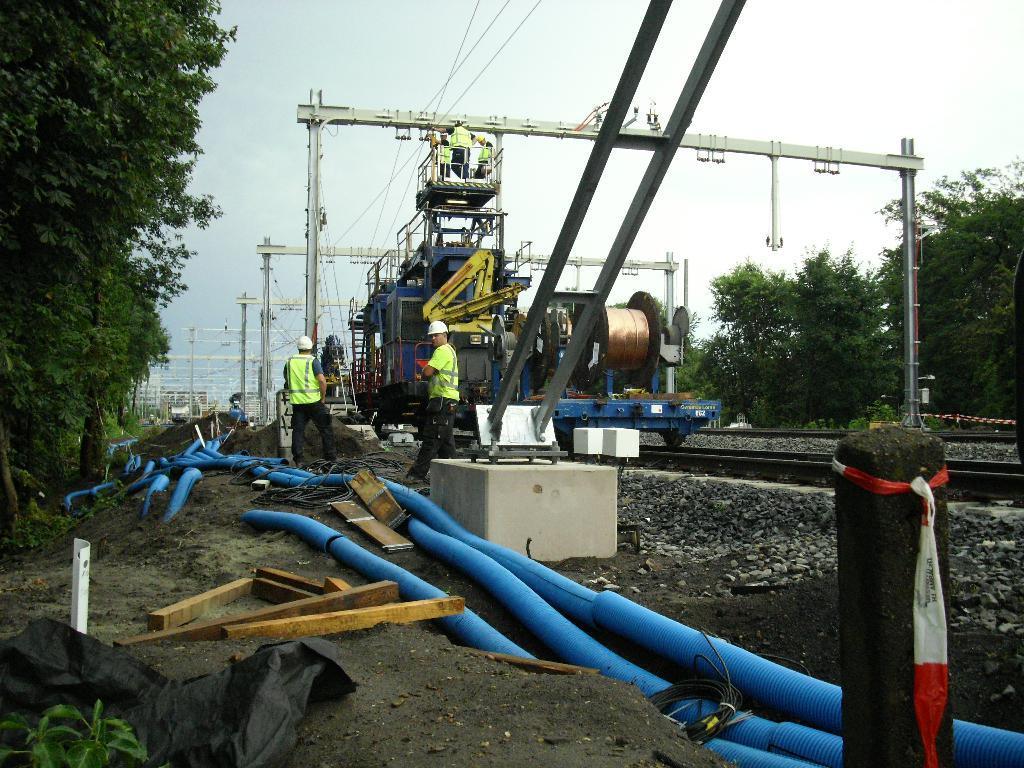Please provide a concise description of this image. On the railway track,there is some repair being going on,there are a lot of pipes and many machines and beside the tracks there are plenty of trees. There are few people standing beside the machines and in the background there is a sky. 